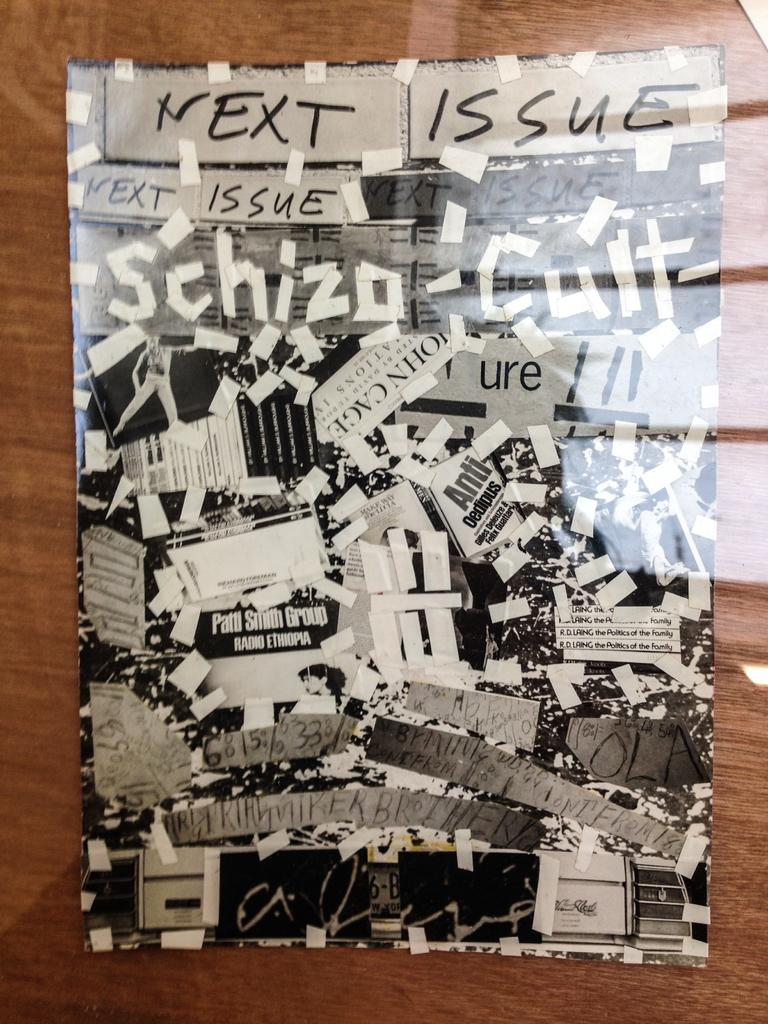What is the main material of the sheet in the image? The main material of the sheet in the image is wood. What is done to the newspapers in the image? The newspapers are cut and pasted on the wooden sheet. What type of structure is being built with the newspapers in the image? There is no structure being built with the newspapers in the image; they are simply cut and pasted on the wooden sheet. 